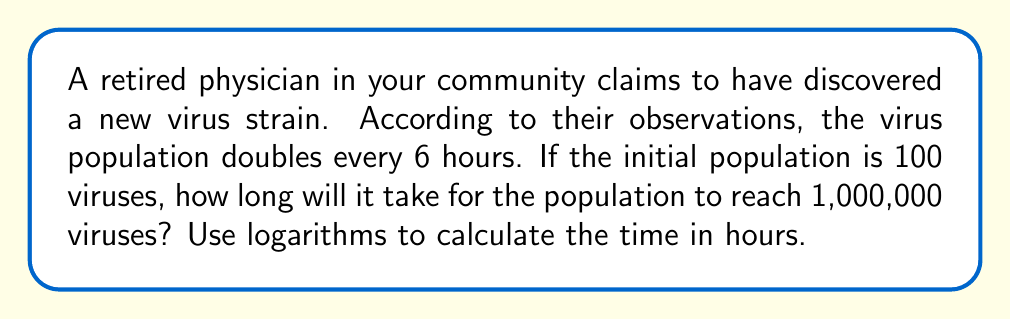What is the answer to this math problem? Let's approach this step-by-step using logarithms:

1) Let $t$ be the time in hours and $N$ be the number of viruses at time $t$.

2) The exponential growth formula is:
   $N = N_0 \cdot 2^{t/6}$
   where $N_0$ is the initial population (100) and 6 is the doubling time in hours.

3) We want to find $t$ when $N = 1,000,000$. Substituting these values:
   $1,000,000 = 100 \cdot 2^{t/6}$

4) Divide both sides by 100:
   $10,000 = 2^{t/6}$

5) Take the logarithm (base 2) of both sides:
   $\log_2(10,000) = \log_2(2^{t/6})$

6) Using the logarithm property $\log_a(a^x) = x$:
   $\log_2(10,000) = t/6$

7) Multiply both sides by 6:
   $6 \cdot \log_2(10,000) = t$

8) Calculate $\log_2(10,000)$:
   $\log_2(10,000) = \frac{\ln(10,000)}{\ln(2)} \approx 13.2877$

9) Therefore:
   $t = 6 \cdot 13.2877 \approx 79.7262$ hours
Answer: $79.73$ hours 